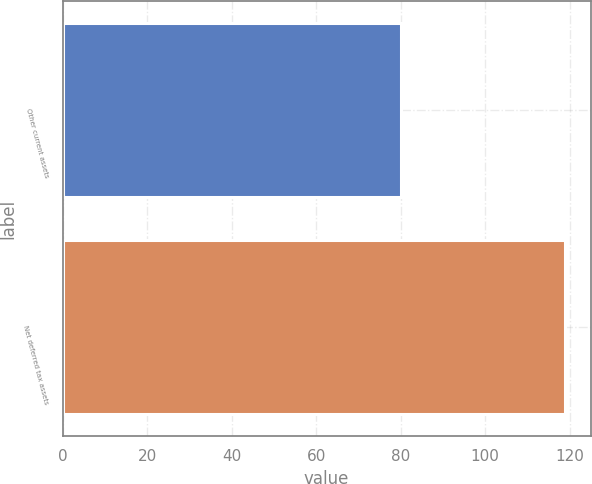Convert chart. <chart><loc_0><loc_0><loc_500><loc_500><bar_chart><fcel>Other current assets<fcel>Net deferred tax assets<nl><fcel>80<fcel>119<nl></chart> 